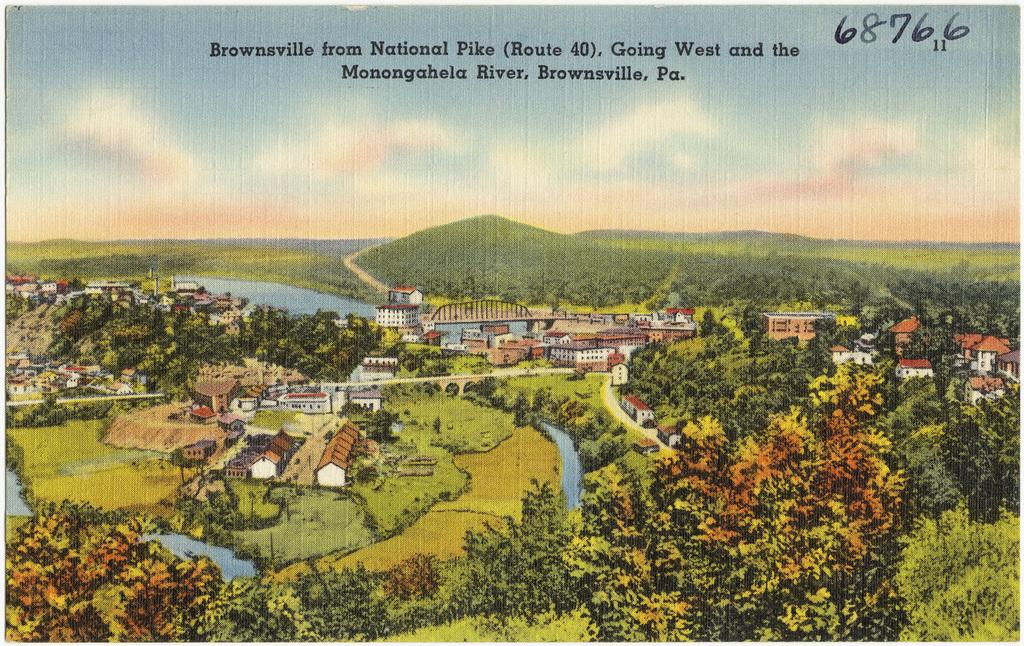<image>
Describe the image concisely. A painting of a landscape with "Brownsville from National Pike" above it. 